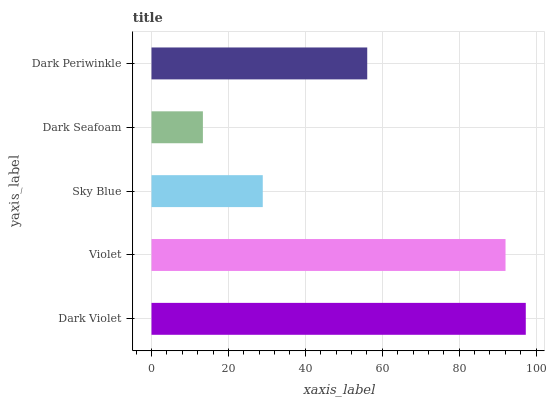Is Dark Seafoam the minimum?
Answer yes or no. Yes. Is Dark Violet the maximum?
Answer yes or no. Yes. Is Violet the minimum?
Answer yes or no. No. Is Violet the maximum?
Answer yes or no. No. Is Dark Violet greater than Violet?
Answer yes or no. Yes. Is Violet less than Dark Violet?
Answer yes or no. Yes. Is Violet greater than Dark Violet?
Answer yes or no. No. Is Dark Violet less than Violet?
Answer yes or no. No. Is Dark Periwinkle the high median?
Answer yes or no. Yes. Is Dark Periwinkle the low median?
Answer yes or no. Yes. Is Sky Blue the high median?
Answer yes or no. No. Is Violet the low median?
Answer yes or no. No. 